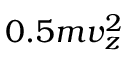Convert formula to latex. <formula><loc_0><loc_0><loc_500><loc_500>0 . 5 m v _ { z } ^ { 2 }</formula> 